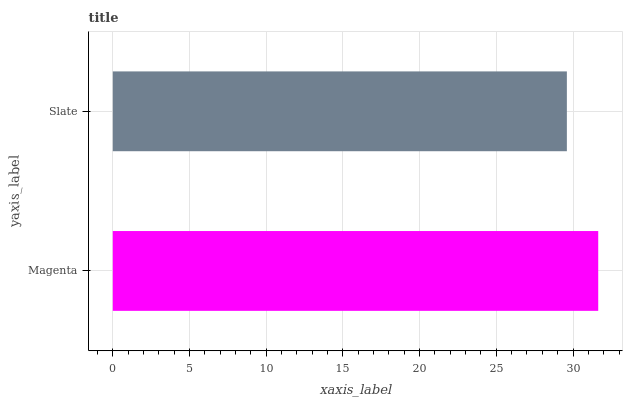Is Slate the minimum?
Answer yes or no. Yes. Is Magenta the maximum?
Answer yes or no. Yes. Is Slate the maximum?
Answer yes or no. No. Is Magenta greater than Slate?
Answer yes or no. Yes. Is Slate less than Magenta?
Answer yes or no. Yes. Is Slate greater than Magenta?
Answer yes or no. No. Is Magenta less than Slate?
Answer yes or no. No. Is Magenta the high median?
Answer yes or no. Yes. Is Slate the low median?
Answer yes or no. Yes. Is Slate the high median?
Answer yes or no. No. Is Magenta the low median?
Answer yes or no. No. 